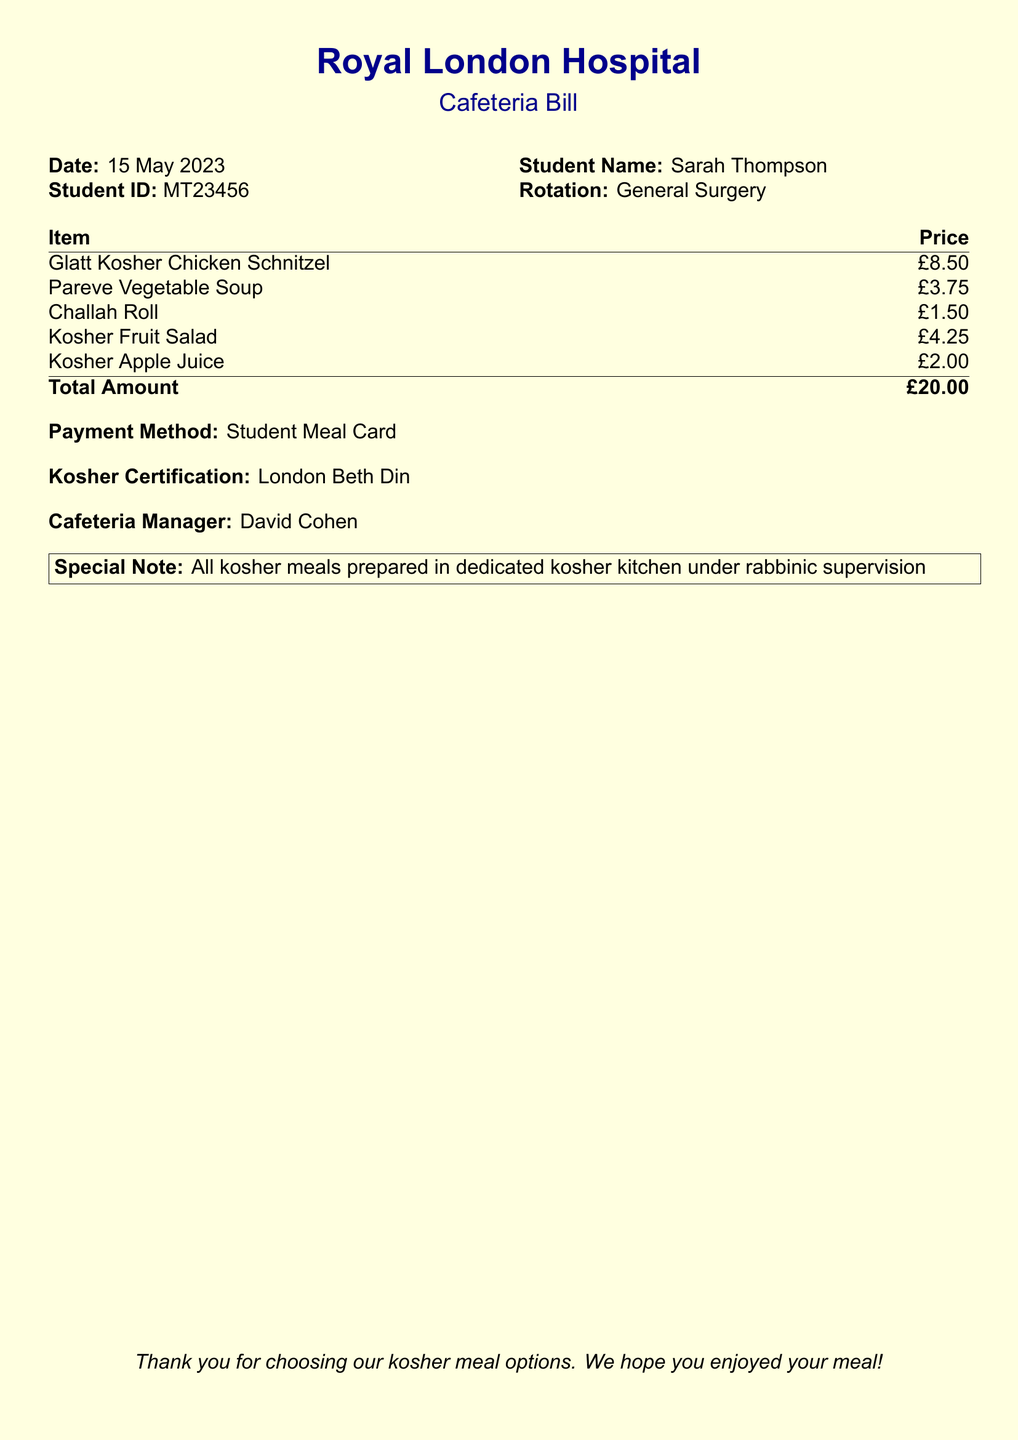what is the date of the bill? The date of the bill is specified in the document, which is found under the "Date" heading.
Answer: 15 May 2023 who is the cafeteria manager? The cafeteria manager's name is listed prominently within the document.
Answer: David Cohen what is the total amount charged? The total amount is detailed at the bottom of the item list in the document.
Answer: £20.00 how many items are listed on the bill? The number of items can be counted from the item list presented in the document.
Answer: 5 what is the name of the student? The student's name is provided alongside the Student ID in the top section of the document.
Answer: Sarah Thompson what method of payment was used? The payment method is clearly stated in the document under payment details.
Answer: Student Meal Card what type of soup is listed as kosher? The specific type of soup is mentioned in the item list.
Answer: Pareve Vegetable Soup who provided the kosher certification? The kosher certification source is mentioned in the document.
Answer: London Beth Din what does the special note indicate? The special note provides information about the kosher food preparation.
Answer: All kosher meals prepared in dedicated kosher kitchen under rabbinic supervision 